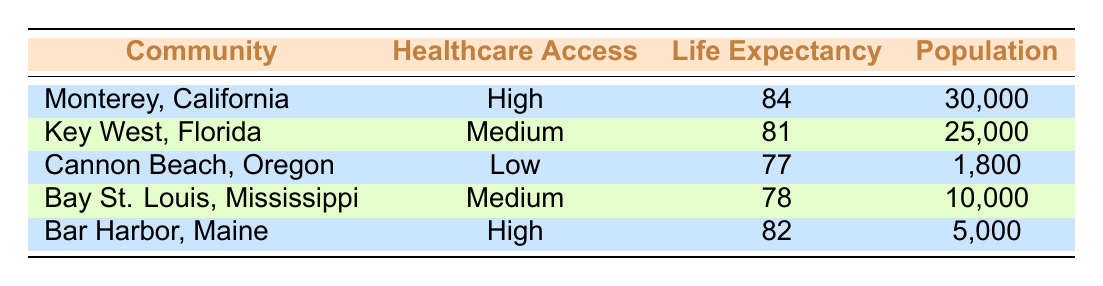What is the average life expectancy in coastal communities with high access to healthcare? The table shows two communities with high access to healthcare: Monterey, California (84 years) and Bar Harbor, Maine (82 years). To find the average, we sum these values: (84 + 82) = 166. There are 2 communities, so the average life expectancy is 166/2 = 83.
Answer: 83 Which coastal community has the highest average life expectancy? By examining the life expectancy values in the table, Monterey, California has the highest average life expectancy at 84 years.
Answer: Monterey, California Is the statement "Cannon Beach, Oregon has a higher life expectancy than Bay St. Louis, Mississippi" true or false? The life expectancy for Cannon Beach, Oregon is 77 years, while for Bay St. Louis, Mississippi, it is 78 years. Since 77 is less than 78, the statement is false.
Answer: False What is the total population of all communities with medium access to healthcare? There are two communities with medium access: Key West, Florida with a population of 25,000 and Bay St. Louis, Mississippi with a population of 10,000. To find the total population, we add these two values: 25,000 + 10,000 = 35,000.
Answer: 35,000 How many communities have an average life expectancy above 80 years? Looking at the table, Monterey, California (84 years) and Bar Harbor, Maine (82 years) have life expectancies above 80. Therefore, there are 2 communities that meet this criterion.
Answer: 2 What is the difference in life expectancy between the community with the highest and lowest access to healthcare? The highest access to healthcare is in Monterey, California with an average life expectancy of 84 years, and the lowest is in Cannon Beach, Oregon with 77 years. The difference is calculated as 84 - 77 = 7 years.
Answer: 7 years 